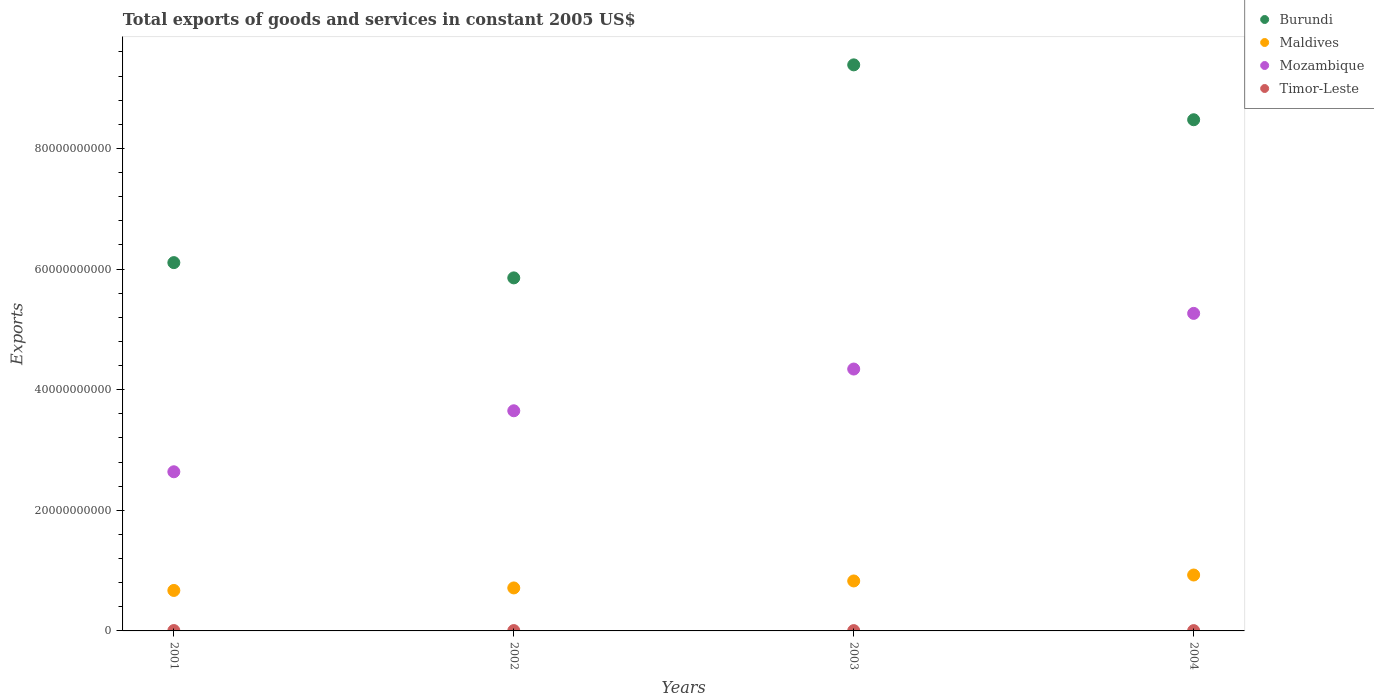What is the total exports of goods and services in Maldives in 2003?
Ensure brevity in your answer.  8.28e+09. Across all years, what is the maximum total exports of goods and services in Maldives?
Give a very brief answer. 9.27e+09. Across all years, what is the minimum total exports of goods and services in Timor-Leste?
Provide a short and direct response. 5.10e+07. What is the total total exports of goods and services in Mozambique in the graph?
Give a very brief answer. 1.59e+11. What is the difference between the total exports of goods and services in Timor-Leste in 2001 and that in 2003?
Keep it short and to the point. 1.00e+07. What is the difference between the total exports of goods and services in Timor-Leste in 2003 and the total exports of goods and services in Maldives in 2001?
Your response must be concise. -6.66e+09. What is the average total exports of goods and services in Burundi per year?
Your answer should be compact. 7.45e+1. In the year 2002, what is the difference between the total exports of goods and services in Timor-Leste and total exports of goods and services in Maldives?
Your answer should be compact. -7.07e+09. What is the ratio of the total exports of goods and services in Burundi in 2001 to that in 2003?
Ensure brevity in your answer.  0.65. Is the total exports of goods and services in Mozambique in 2003 less than that in 2004?
Your response must be concise. Yes. Is the difference between the total exports of goods and services in Timor-Leste in 2001 and 2002 greater than the difference between the total exports of goods and services in Maldives in 2001 and 2002?
Keep it short and to the point. Yes. What is the difference between the highest and the second highest total exports of goods and services in Mozambique?
Keep it short and to the point. 9.23e+09. What is the difference between the highest and the lowest total exports of goods and services in Timor-Leste?
Your response must be concise. 1.10e+07. In how many years, is the total exports of goods and services in Timor-Leste greater than the average total exports of goods and services in Timor-Leste taken over all years?
Offer a very short reply. 2. Is it the case that in every year, the sum of the total exports of goods and services in Timor-Leste and total exports of goods and services in Maldives  is greater than the total exports of goods and services in Burundi?
Your answer should be very brief. No. Is the total exports of goods and services in Timor-Leste strictly less than the total exports of goods and services in Maldives over the years?
Your response must be concise. Yes. How many years are there in the graph?
Your answer should be very brief. 4. Are the values on the major ticks of Y-axis written in scientific E-notation?
Your response must be concise. No. Where does the legend appear in the graph?
Provide a succinct answer. Top right. How many legend labels are there?
Offer a terse response. 4. How are the legend labels stacked?
Offer a terse response. Vertical. What is the title of the graph?
Offer a terse response. Total exports of goods and services in constant 2005 US$. What is the label or title of the X-axis?
Ensure brevity in your answer.  Years. What is the label or title of the Y-axis?
Give a very brief answer. Exports. What is the Exports in Burundi in 2001?
Offer a terse response. 6.11e+1. What is the Exports of Maldives in 2001?
Offer a terse response. 6.71e+09. What is the Exports of Mozambique in 2001?
Keep it short and to the point. 2.64e+1. What is the Exports in Timor-Leste in 2001?
Provide a short and direct response. 6.20e+07. What is the Exports of Burundi in 2002?
Offer a very short reply. 5.85e+1. What is the Exports in Maldives in 2002?
Provide a short and direct response. 7.13e+09. What is the Exports in Mozambique in 2002?
Your answer should be compact. 3.65e+1. What is the Exports in Timor-Leste in 2002?
Give a very brief answer. 5.70e+07. What is the Exports in Burundi in 2003?
Make the answer very short. 9.39e+1. What is the Exports of Maldives in 2003?
Keep it short and to the point. 8.28e+09. What is the Exports of Mozambique in 2003?
Ensure brevity in your answer.  4.34e+1. What is the Exports in Timor-Leste in 2003?
Give a very brief answer. 5.20e+07. What is the Exports of Burundi in 2004?
Offer a very short reply. 8.48e+1. What is the Exports of Maldives in 2004?
Provide a short and direct response. 9.27e+09. What is the Exports in Mozambique in 2004?
Offer a very short reply. 5.26e+1. What is the Exports of Timor-Leste in 2004?
Make the answer very short. 5.10e+07. Across all years, what is the maximum Exports in Burundi?
Make the answer very short. 9.39e+1. Across all years, what is the maximum Exports of Maldives?
Offer a terse response. 9.27e+09. Across all years, what is the maximum Exports in Mozambique?
Keep it short and to the point. 5.26e+1. Across all years, what is the maximum Exports in Timor-Leste?
Make the answer very short. 6.20e+07. Across all years, what is the minimum Exports of Burundi?
Offer a very short reply. 5.85e+1. Across all years, what is the minimum Exports of Maldives?
Keep it short and to the point. 6.71e+09. Across all years, what is the minimum Exports of Mozambique?
Your response must be concise. 2.64e+1. Across all years, what is the minimum Exports in Timor-Leste?
Give a very brief answer. 5.10e+07. What is the total Exports in Burundi in the graph?
Your response must be concise. 2.98e+11. What is the total Exports of Maldives in the graph?
Offer a very short reply. 3.14e+1. What is the total Exports in Mozambique in the graph?
Make the answer very short. 1.59e+11. What is the total Exports of Timor-Leste in the graph?
Ensure brevity in your answer.  2.22e+08. What is the difference between the Exports of Burundi in 2001 and that in 2002?
Provide a succinct answer. 2.53e+09. What is the difference between the Exports in Maldives in 2001 and that in 2002?
Your response must be concise. -4.16e+08. What is the difference between the Exports of Mozambique in 2001 and that in 2002?
Keep it short and to the point. -1.01e+1. What is the difference between the Exports of Timor-Leste in 2001 and that in 2002?
Your answer should be very brief. 5.00e+06. What is the difference between the Exports in Burundi in 2001 and that in 2003?
Ensure brevity in your answer.  -3.28e+1. What is the difference between the Exports of Maldives in 2001 and that in 2003?
Offer a terse response. -1.57e+09. What is the difference between the Exports of Mozambique in 2001 and that in 2003?
Provide a short and direct response. -1.70e+1. What is the difference between the Exports of Timor-Leste in 2001 and that in 2003?
Provide a succinct answer. 1.00e+07. What is the difference between the Exports in Burundi in 2001 and that in 2004?
Your answer should be compact. -2.37e+1. What is the difference between the Exports in Maldives in 2001 and that in 2004?
Your answer should be compact. -2.56e+09. What is the difference between the Exports of Mozambique in 2001 and that in 2004?
Offer a terse response. -2.63e+1. What is the difference between the Exports in Timor-Leste in 2001 and that in 2004?
Your response must be concise. 1.10e+07. What is the difference between the Exports in Burundi in 2002 and that in 2003?
Offer a very short reply. -3.53e+1. What is the difference between the Exports in Maldives in 2002 and that in 2003?
Provide a short and direct response. -1.16e+09. What is the difference between the Exports in Mozambique in 2002 and that in 2003?
Provide a succinct answer. -6.92e+09. What is the difference between the Exports of Timor-Leste in 2002 and that in 2003?
Your answer should be compact. 5.00e+06. What is the difference between the Exports of Burundi in 2002 and that in 2004?
Offer a terse response. -2.62e+1. What is the difference between the Exports of Maldives in 2002 and that in 2004?
Offer a very short reply. -2.14e+09. What is the difference between the Exports of Mozambique in 2002 and that in 2004?
Provide a succinct answer. -1.61e+1. What is the difference between the Exports in Timor-Leste in 2002 and that in 2004?
Offer a terse response. 6.00e+06. What is the difference between the Exports of Burundi in 2003 and that in 2004?
Your answer should be very brief. 9.10e+09. What is the difference between the Exports in Maldives in 2003 and that in 2004?
Make the answer very short. -9.85e+08. What is the difference between the Exports of Mozambique in 2003 and that in 2004?
Your answer should be compact. -9.23e+09. What is the difference between the Exports of Burundi in 2001 and the Exports of Maldives in 2002?
Offer a very short reply. 5.39e+1. What is the difference between the Exports of Burundi in 2001 and the Exports of Mozambique in 2002?
Keep it short and to the point. 2.46e+1. What is the difference between the Exports of Burundi in 2001 and the Exports of Timor-Leste in 2002?
Provide a succinct answer. 6.10e+1. What is the difference between the Exports in Maldives in 2001 and the Exports in Mozambique in 2002?
Your answer should be compact. -2.98e+1. What is the difference between the Exports of Maldives in 2001 and the Exports of Timor-Leste in 2002?
Make the answer very short. 6.65e+09. What is the difference between the Exports of Mozambique in 2001 and the Exports of Timor-Leste in 2002?
Offer a very short reply. 2.63e+1. What is the difference between the Exports of Burundi in 2001 and the Exports of Maldives in 2003?
Give a very brief answer. 5.28e+1. What is the difference between the Exports of Burundi in 2001 and the Exports of Mozambique in 2003?
Your answer should be compact. 1.76e+1. What is the difference between the Exports of Burundi in 2001 and the Exports of Timor-Leste in 2003?
Provide a short and direct response. 6.10e+1. What is the difference between the Exports of Maldives in 2001 and the Exports of Mozambique in 2003?
Offer a very short reply. -3.67e+1. What is the difference between the Exports of Maldives in 2001 and the Exports of Timor-Leste in 2003?
Provide a short and direct response. 6.66e+09. What is the difference between the Exports of Mozambique in 2001 and the Exports of Timor-Leste in 2003?
Your response must be concise. 2.63e+1. What is the difference between the Exports of Burundi in 2001 and the Exports of Maldives in 2004?
Your answer should be very brief. 5.18e+1. What is the difference between the Exports of Burundi in 2001 and the Exports of Mozambique in 2004?
Your answer should be very brief. 8.42e+09. What is the difference between the Exports of Burundi in 2001 and the Exports of Timor-Leste in 2004?
Your answer should be compact. 6.10e+1. What is the difference between the Exports in Maldives in 2001 and the Exports in Mozambique in 2004?
Provide a short and direct response. -4.59e+1. What is the difference between the Exports in Maldives in 2001 and the Exports in Timor-Leste in 2004?
Offer a very short reply. 6.66e+09. What is the difference between the Exports in Mozambique in 2001 and the Exports in Timor-Leste in 2004?
Provide a succinct answer. 2.63e+1. What is the difference between the Exports of Burundi in 2002 and the Exports of Maldives in 2003?
Your answer should be compact. 5.02e+1. What is the difference between the Exports in Burundi in 2002 and the Exports in Mozambique in 2003?
Your answer should be very brief. 1.51e+1. What is the difference between the Exports in Burundi in 2002 and the Exports in Timor-Leste in 2003?
Make the answer very short. 5.85e+1. What is the difference between the Exports of Maldives in 2002 and the Exports of Mozambique in 2003?
Provide a short and direct response. -3.63e+1. What is the difference between the Exports in Maldives in 2002 and the Exports in Timor-Leste in 2003?
Give a very brief answer. 7.07e+09. What is the difference between the Exports of Mozambique in 2002 and the Exports of Timor-Leste in 2003?
Keep it short and to the point. 3.64e+1. What is the difference between the Exports in Burundi in 2002 and the Exports in Maldives in 2004?
Provide a succinct answer. 4.93e+1. What is the difference between the Exports in Burundi in 2002 and the Exports in Mozambique in 2004?
Offer a very short reply. 5.89e+09. What is the difference between the Exports of Burundi in 2002 and the Exports of Timor-Leste in 2004?
Provide a short and direct response. 5.85e+1. What is the difference between the Exports of Maldives in 2002 and the Exports of Mozambique in 2004?
Ensure brevity in your answer.  -4.55e+1. What is the difference between the Exports of Maldives in 2002 and the Exports of Timor-Leste in 2004?
Offer a terse response. 7.08e+09. What is the difference between the Exports in Mozambique in 2002 and the Exports in Timor-Leste in 2004?
Provide a short and direct response. 3.64e+1. What is the difference between the Exports of Burundi in 2003 and the Exports of Maldives in 2004?
Make the answer very short. 8.46e+1. What is the difference between the Exports in Burundi in 2003 and the Exports in Mozambique in 2004?
Provide a short and direct response. 4.12e+1. What is the difference between the Exports of Burundi in 2003 and the Exports of Timor-Leste in 2004?
Your answer should be compact. 9.38e+1. What is the difference between the Exports in Maldives in 2003 and the Exports in Mozambique in 2004?
Your answer should be very brief. -4.44e+1. What is the difference between the Exports of Maldives in 2003 and the Exports of Timor-Leste in 2004?
Offer a terse response. 8.23e+09. What is the difference between the Exports in Mozambique in 2003 and the Exports in Timor-Leste in 2004?
Ensure brevity in your answer.  4.34e+1. What is the average Exports in Burundi per year?
Ensure brevity in your answer.  7.45e+1. What is the average Exports of Maldives per year?
Ensure brevity in your answer.  7.85e+09. What is the average Exports of Mozambique per year?
Provide a short and direct response. 3.97e+1. What is the average Exports of Timor-Leste per year?
Keep it short and to the point. 5.55e+07. In the year 2001, what is the difference between the Exports of Burundi and Exports of Maldives?
Provide a short and direct response. 5.44e+1. In the year 2001, what is the difference between the Exports in Burundi and Exports in Mozambique?
Give a very brief answer. 3.47e+1. In the year 2001, what is the difference between the Exports of Burundi and Exports of Timor-Leste?
Your answer should be very brief. 6.10e+1. In the year 2001, what is the difference between the Exports of Maldives and Exports of Mozambique?
Ensure brevity in your answer.  -1.97e+1. In the year 2001, what is the difference between the Exports of Maldives and Exports of Timor-Leste?
Your response must be concise. 6.65e+09. In the year 2001, what is the difference between the Exports in Mozambique and Exports in Timor-Leste?
Make the answer very short. 2.63e+1. In the year 2002, what is the difference between the Exports in Burundi and Exports in Maldives?
Offer a terse response. 5.14e+1. In the year 2002, what is the difference between the Exports in Burundi and Exports in Mozambique?
Provide a succinct answer. 2.20e+1. In the year 2002, what is the difference between the Exports in Burundi and Exports in Timor-Leste?
Ensure brevity in your answer.  5.85e+1. In the year 2002, what is the difference between the Exports in Maldives and Exports in Mozambique?
Make the answer very short. -2.94e+1. In the year 2002, what is the difference between the Exports of Maldives and Exports of Timor-Leste?
Make the answer very short. 7.07e+09. In the year 2002, what is the difference between the Exports in Mozambique and Exports in Timor-Leste?
Your answer should be compact. 3.64e+1. In the year 2003, what is the difference between the Exports in Burundi and Exports in Maldives?
Keep it short and to the point. 8.56e+1. In the year 2003, what is the difference between the Exports in Burundi and Exports in Mozambique?
Make the answer very short. 5.04e+1. In the year 2003, what is the difference between the Exports in Burundi and Exports in Timor-Leste?
Keep it short and to the point. 9.38e+1. In the year 2003, what is the difference between the Exports in Maldives and Exports in Mozambique?
Give a very brief answer. -3.51e+1. In the year 2003, what is the difference between the Exports of Maldives and Exports of Timor-Leste?
Your response must be concise. 8.23e+09. In the year 2003, what is the difference between the Exports in Mozambique and Exports in Timor-Leste?
Offer a terse response. 4.34e+1. In the year 2004, what is the difference between the Exports of Burundi and Exports of Maldives?
Give a very brief answer. 7.55e+1. In the year 2004, what is the difference between the Exports in Burundi and Exports in Mozambique?
Provide a succinct answer. 3.21e+1. In the year 2004, what is the difference between the Exports in Burundi and Exports in Timor-Leste?
Your answer should be compact. 8.47e+1. In the year 2004, what is the difference between the Exports in Maldives and Exports in Mozambique?
Your response must be concise. -4.34e+1. In the year 2004, what is the difference between the Exports of Maldives and Exports of Timor-Leste?
Your response must be concise. 9.22e+09. In the year 2004, what is the difference between the Exports in Mozambique and Exports in Timor-Leste?
Provide a succinct answer. 5.26e+1. What is the ratio of the Exports of Burundi in 2001 to that in 2002?
Your answer should be compact. 1.04. What is the ratio of the Exports in Maldives in 2001 to that in 2002?
Ensure brevity in your answer.  0.94. What is the ratio of the Exports in Mozambique in 2001 to that in 2002?
Offer a terse response. 0.72. What is the ratio of the Exports of Timor-Leste in 2001 to that in 2002?
Give a very brief answer. 1.09. What is the ratio of the Exports of Burundi in 2001 to that in 2003?
Keep it short and to the point. 0.65. What is the ratio of the Exports of Maldives in 2001 to that in 2003?
Your answer should be very brief. 0.81. What is the ratio of the Exports of Mozambique in 2001 to that in 2003?
Your answer should be very brief. 0.61. What is the ratio of the Exports in Timor-Leste in 2001 to that in 2003?
Keep it short and to the point. 1.19. What is the ratio of the Exports of Burundi in 2001 to that in 2004?
Keep it short and to the point. 0.72. What is the ratio of the Exports of Maldives in 2001 to that in 2004?
Offer a terse response. 0.72. What is the ratio of the Exports in Mozambique in 2001 to that in 2004?
Your answer should be compact. 0.5. What is the ratio of the Exports in Timor-Leste in 2001 to that in 2004?
Provide a short and direct response. 1.22. What is the ratio of the Exports in Burundi in 2002 to that in 2003?
Make the answer very short. 0.62. What is the ratio of the Exports of Maldives in 2002 to that in 2003?
Provide a succinct answer. 0.86. What is the ratio of the Exports of Mozambique in 2002 to that in 2003?
Your answer should be very brief. 0.84. What is the ratio of the Exports of Timor-Leste in 2002 to that in 2003?
Your response must be concise. 1.1. What is the ratio of the Exports in Burundi in 2002 to that in 2004?
Offer a very short reply. 0.69. What is the ratio of the Exports of Maldives in 2002 to that in 2004?
Provide a succinct answer. 0.77. What is the ratio of the Exports in Mozambique in 2002 to that in 2004?
Offer a very short reply. 0.69. What is the ratio of the Exports of Timor-Leste in 2002 to that in 2004?
Provide a succinct answer. 1.12. What is the ratio of the Exports of Burundi in 2003 to that in 2004?
Give a very brief answer. 1.11. What is the ratio of the Exports in Maldives in 2003 to that in 2004?
Give a very brief answer. 0.89. What is the ratio of the Exports of Mozambique in 2003 to that in 2004?
Provide a short and direct response. 0.82. What is the ratio of the Exports of Timor-Leste in 2003 to that in 2004?
Your answer should be very brief. 1.02. What is the difference between the highest and the second highest Exports of Burundi?
Offer a terse response. 9.10e+09. What is the difference between the highest and the second highest Exports in Maldives?
Offer a terse response. 9.85e+08. What is the difference between the highest and the second highest Exports in Mozambique?
Your answer should be very brief. 9.23e+09. What is the difference between the highest and the second highest Exports in Timor-Leste?
Offer a very short reply. 5.00e+06. What is the difference between the highest and the lowest Exports of Burundi?
Provide a short and direct response. 3.53e+1. What is the difference between the highest and the lowest Exports of Maldives?
Keep it short and to the point. 2.56e+09. What is the difference between the highest and the lowest Exports in Mozambique?
Ensure brevity in your answer.  2.63e+1. What is the difference between the highest and the lowest Exports of Timor-Leste?
Your response must be concise. 1.10e+07. 